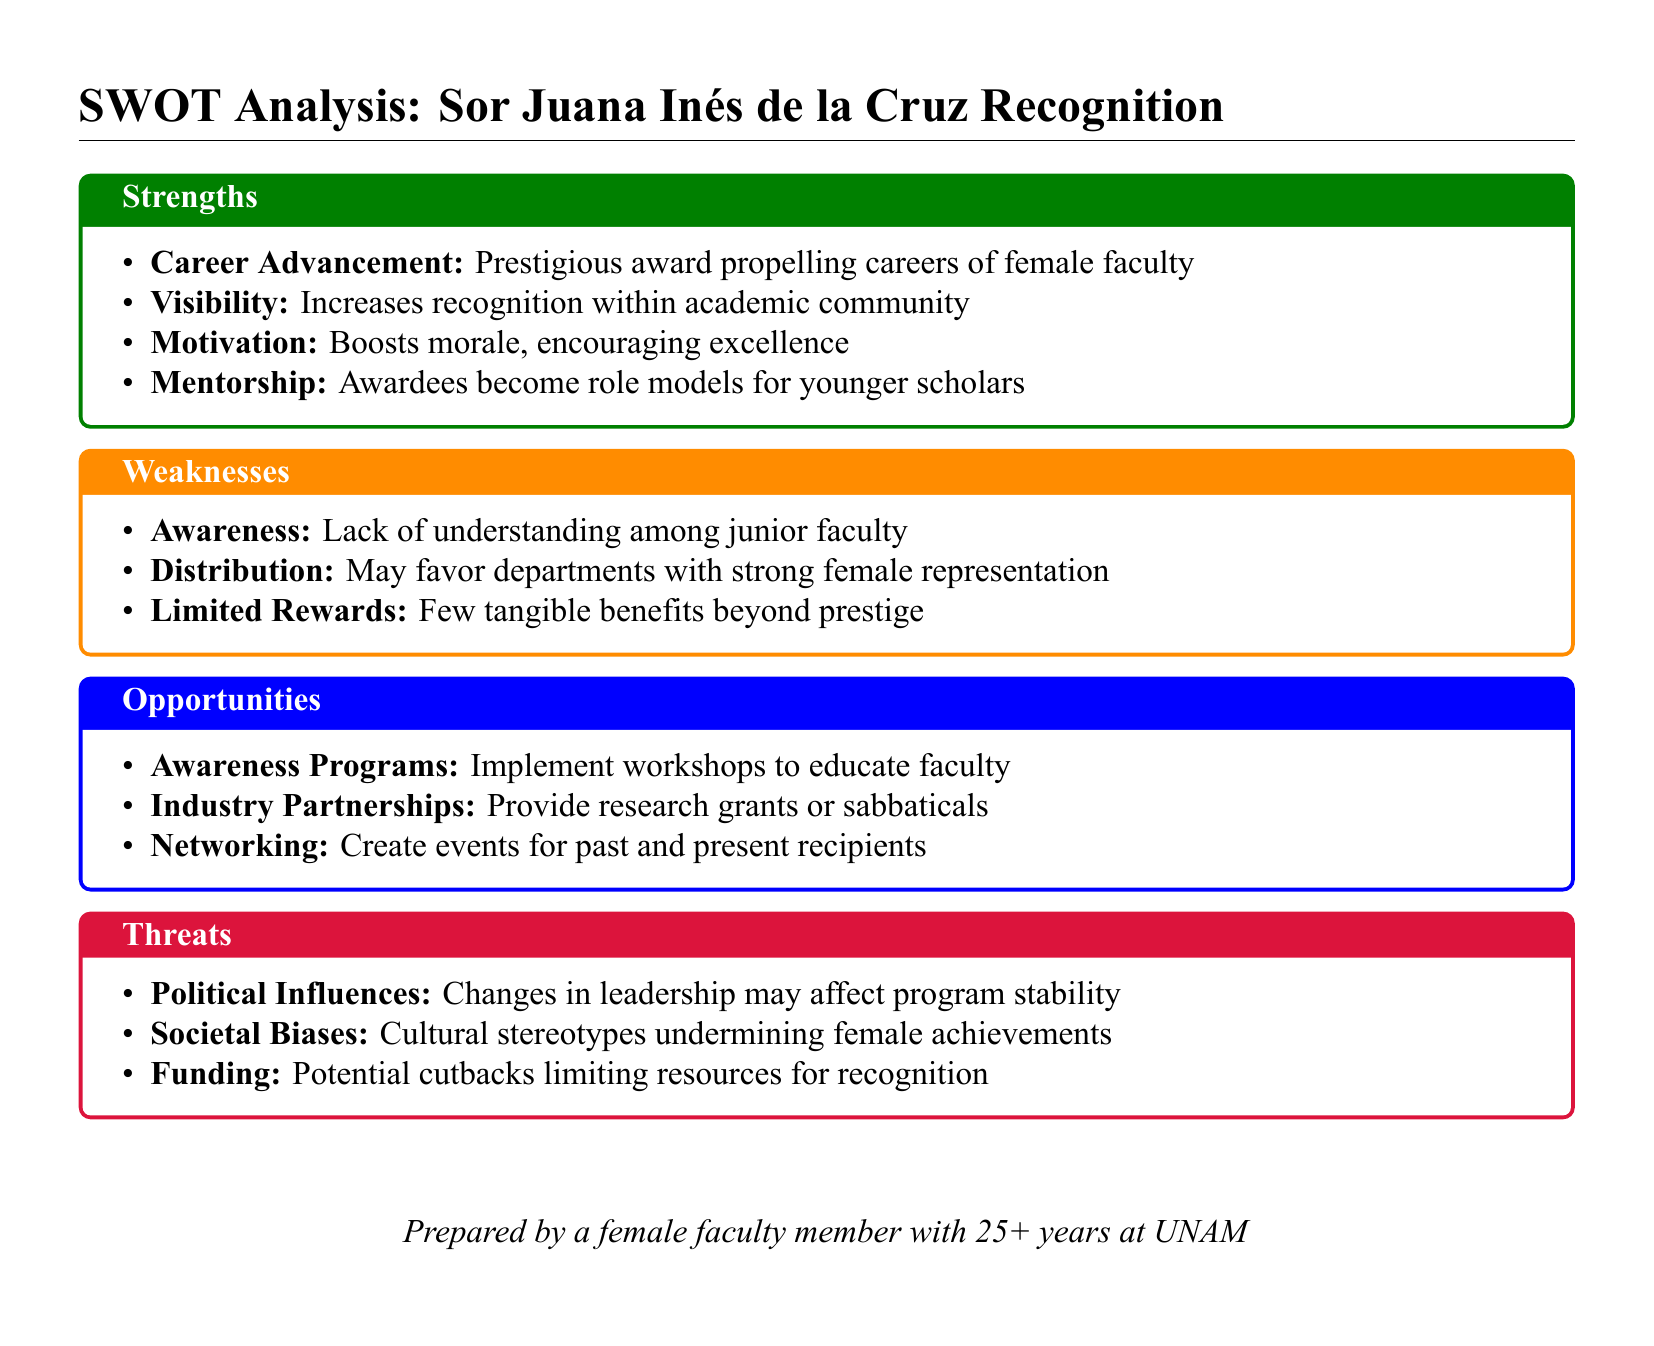what is the title of the analysis? The title indicates the focus of the analysis regarding female faculty members, specifically the recognition.
Answer: SWOT Analysis: Sor Juana Inés de la Cruz Recognition how many strengths are listed in the document? The document lists four strengths under the Strengths section.
Answer: 4 what is one identified weakness regarding the award's awareness? The weakness mentions a lack of understanding among a specific group related to the recognition.
Answer: Lack of understanding among junior faculty name a potential opportunity suggested for enhancing the recognition program. One of the suggested opportunities is to implement educational initiatives for faculty.
Answer: Awareness Programs what is a threat related to political influences? The document highlights that changes in leadership might impact the program's continuity or stability.
Answer: Changes in leadership may affect program stability which area reports limited tangible benefits? The Weaknesses section specifically mentions this issue regarding the award.
Answer: Few tangible benefits beyond prestige what motivates recipients according to the strengths listed? The document emphasizes the motivational aspect that comes from receiving the recognition.
Answer: Boosts morale, encouraging excellence how many threats are identified in the analysis? There are three threats mentioned in the document under the Threats section.
Answer: 3 